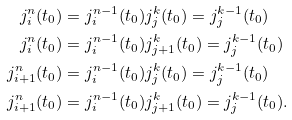<formula> <loc_0><loc_0><loc_500><loc_500>j ^ { n } _ { i } ( t _ { 0 } ) & = j ^ { n - 1 } _ { i } ( t _ { 0 } ) j ^ { k } _ { j } ( t _ { 0 } ) = j ^ { k - 1 } _ { j } ( t _ { 0 } ) \\ j ^ { n } _ { i } ( t _ { 0 } ) & = j ^ { n - 1 } _ { i } ( t _ { 0 } ) j ^ { k } _ { j + 1 } ( t _ { 0 } ) = j ^ { k - 1 } _ { j } ( t _ { 0 } ) \\ j ^ { n } _ { i + 1 } ( t _ { 0 } ) & = j ^ { n - 1 } _ { i } ( t _ { 0 } ) j ^ { k } _ { j } ( t _ { 0 } ) = j ^ { k - 1 } _ { j } ( t _ { 0 } ) \\ j ^ { n } _ { i + 1 } ( t _ { 0 } ) & = j ^ { n - 1 } _ { i } ( t _ { 0 } ) j ^ { k } _ { j + 1 } ( t _ { 0 } ) = j ^ { k - 1 } _ { j } ( t _ { 0 } ) .</formula> 